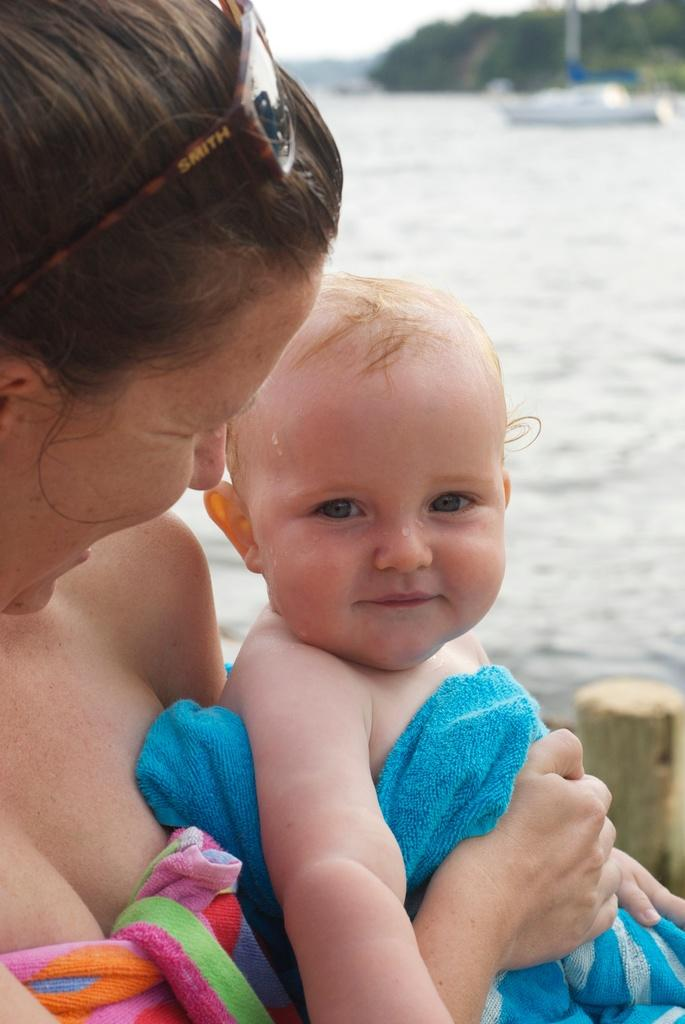What is the woman in the image holding? The woman is holding a baby in the image. What can be seen in the background of the image? There is a wooden log, water, a boat, and trees visible in the background of the image. What item is near the woman in the image? Goggles are near the woman in the image. How many quinces are being burned in the image? There are no quinces or any indication of burning in the image. 